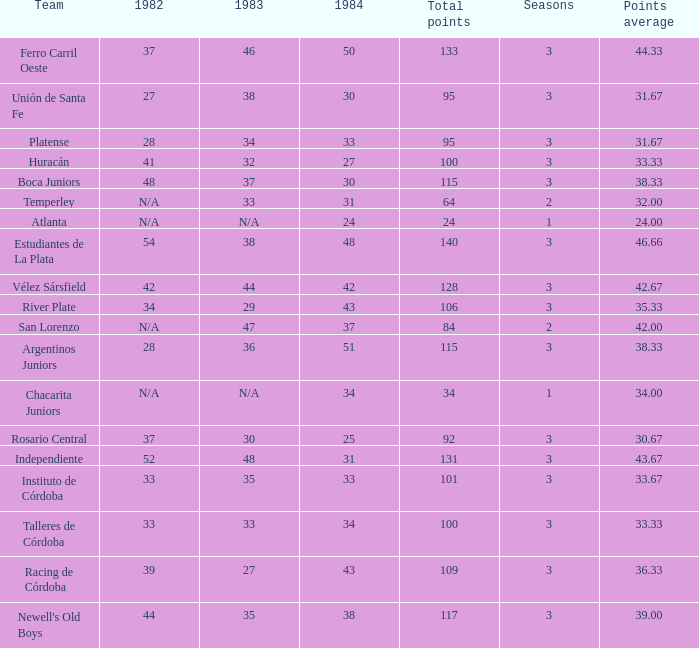Which group had 3 seasons and less than 27 in 1984? Rosario Central. 